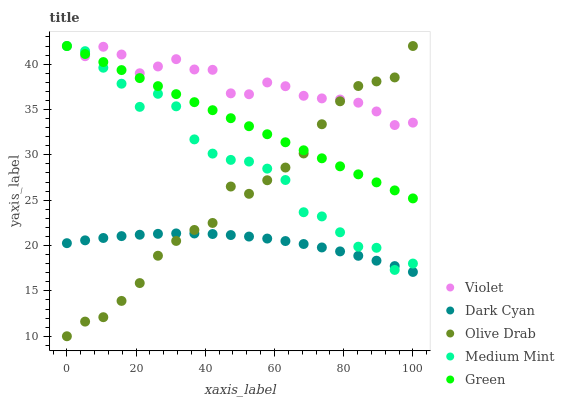Does Dark Cyan have the minimum area under the curve?
Answer yes or no. Yes. Does Violet have the maximum area under the curve?
Answer yes or no. Yes. Does Medium Mint have the minimum area under the curve?
Answer yes or no. No. Does Medium Mint have the maximum area under the curve?
Answer yes or no. No. Is Green the smoothest?
Answer yes or no. Yes. Is Medium Mint the roughest?
Answer yes or no. Yes. Is Medium Mint the smoothest?
Answer yes or no. No. Is Green the roughest?
Answer yes or no. No. Does Olive Drab have the lowest value?
Answer yes or no. Yes. Does Medium Mint have the lowest value?
Answer yes or no. No. Does Violet have the highest value?
Answer yes or no. Yes. Is Dark Cyan less than Violet?
Answer yes or no. Yes. Is Green greater than Dark Cyan?
Answer yes or no. Yes. Does Violet intersect Green?
Answer yes or no. Yes. Is Violet less than Green?
Answer yes or no. No. Is Violet greater than Green?
Answer yes or no. No. Does Dark Cyan intersect Violet?
Answer yes or no. No. 